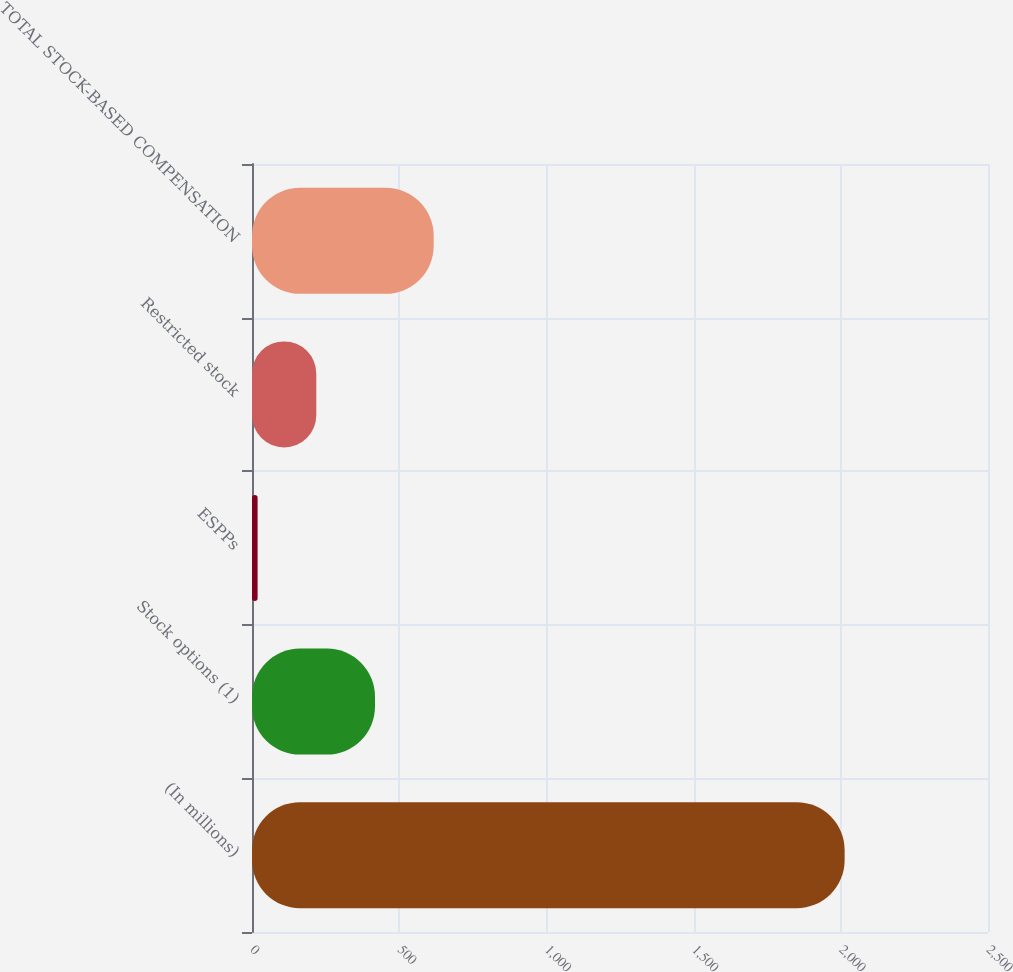Convert chart to OTSL. <chart><loc_0><loc_0><loc_500><loc_500><bar_chart><fcel>(In millions)<fcel>Stock options (1)<fcel>ESPPs<fcel>Restricted stock<fcel>TOTAL STOCK-BASED COMPENSATION<nl><fcel>2013<fcel>417.8<fcel>19<fcel>218.4<fcel>617.2<nl></chart> 